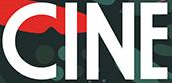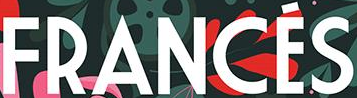Transcribe the words shown in these images in order, separated by a semicolon. CINE; FRANCÉS 